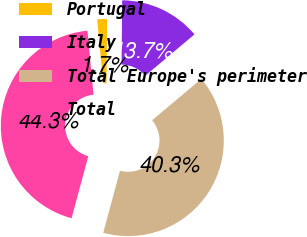<chart> <loc_0><loc_0><loc_500><loc_500><pie_chart><fcel>Portugal<fcel>Italy<fcel>Total Europe's perimeter<fcel>Total<nl><fcel>1.66%<fcel>13.72%<fcel>40.32%<fcel>44.31%<nl></chart> 